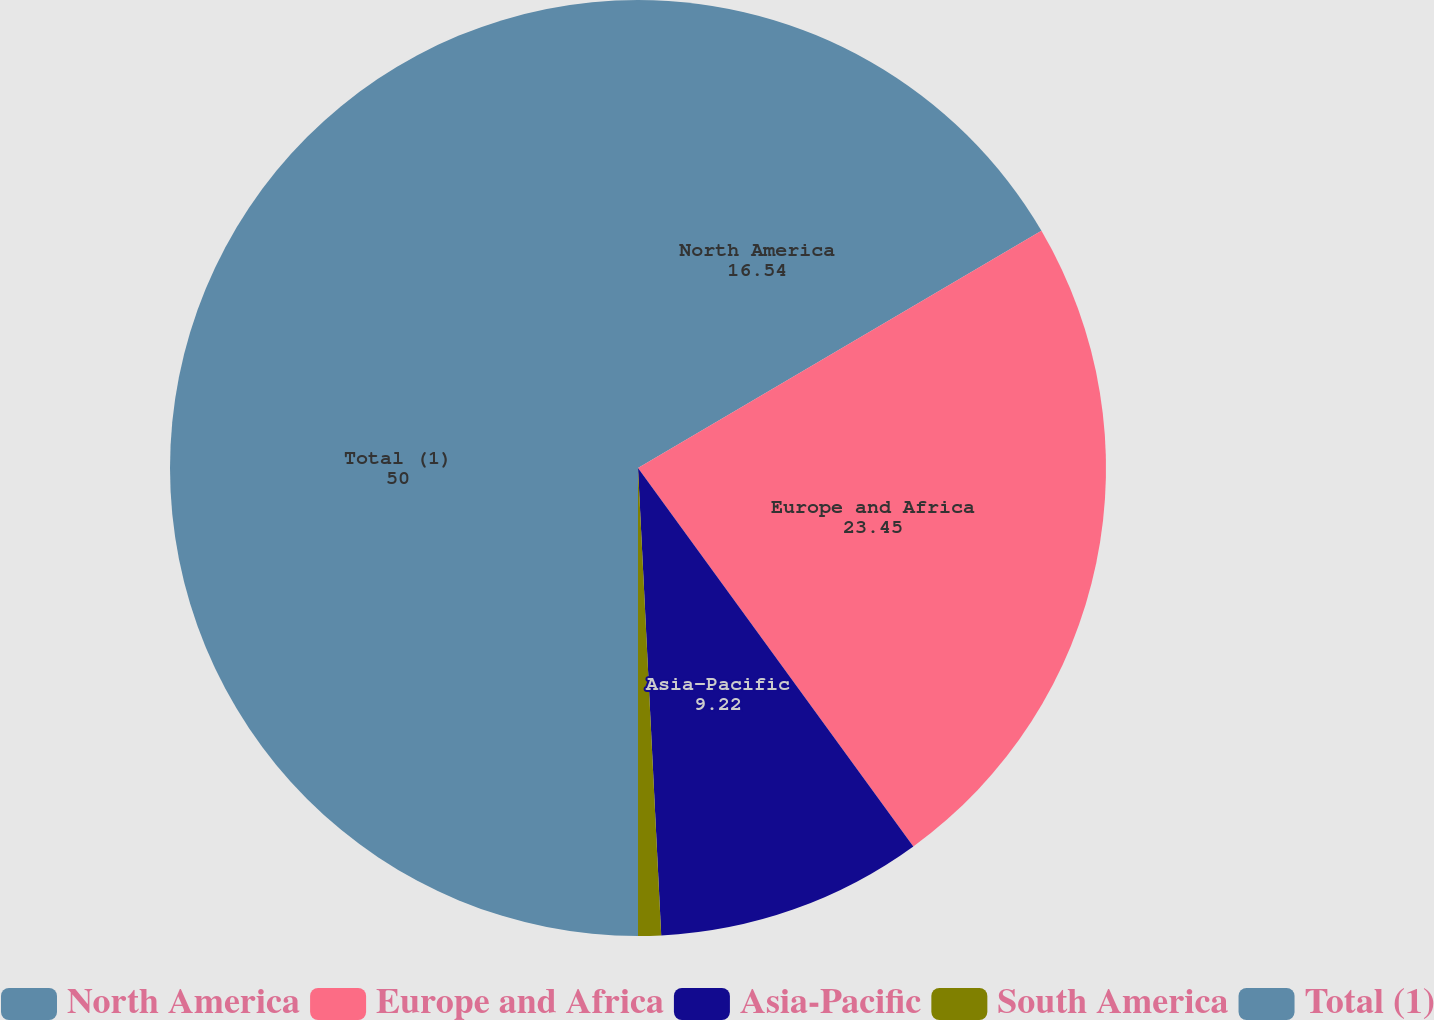<chart> <loc_0><loc_0><loc_500><loc_500><pie_chart><fcel>North America<fcel>Europe and Africa<fcel>Asia-Pacific<fcel>South America<fcel>Total (1)<nl><fcel>16.54%<fcel>23.45%<fcel>9.22%<fcel>0.79%<fcel>50.0%<nl></chart> 